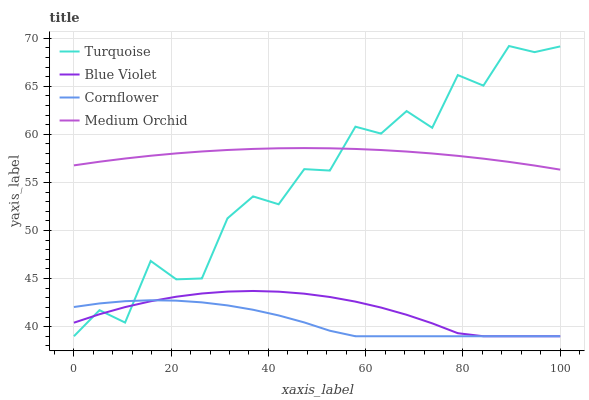Does Cornflower have the minimum area under the curve?
Answer yes or no. Yes. Does Medium Orchid have the maximum area under the curve?
Answer yes or no. Yes. Does Turquoise have the minimum area under the curve?
Answer yes or no. No. Does Turquoise have the maximum area under the curve?
Answer yes or no. No. Is Medium Orchid the smoothest?
Answer yes or no. Yes. Is Turquoise the roughest?
Answer yes or no. Yes. Is Turquoise the smoothest?
Answer yes or no. No. Is Medium Orchid the roughest?
Answer yes or no. No. Does Cornflower have the lowest value?
Answer yes or no. Yes. Does Medium Orchid have the lowest value?
Answer yes or no. No. Does Turquoise have the highest value?
Answer yes or no. Yes. Does Medium Orchid have the highest value?
Answer yes or no. No. Is Cornflower less than Medium Orchid?
Answer yes or no. Yes. Is Medium Orchid greater than Blue Violet?
Answer yes or no. Yes. Does Turquoise intersect Blue Violet?
Answer yes or no. Yes. Is Turquoise less than Blue Violet?
Answer yes or no. No. Is Turquoise greater than Blue Violet?
Answer yes or no. No. Does Cornflower intersect Medium Orchid?
Answer yes or no. No. 